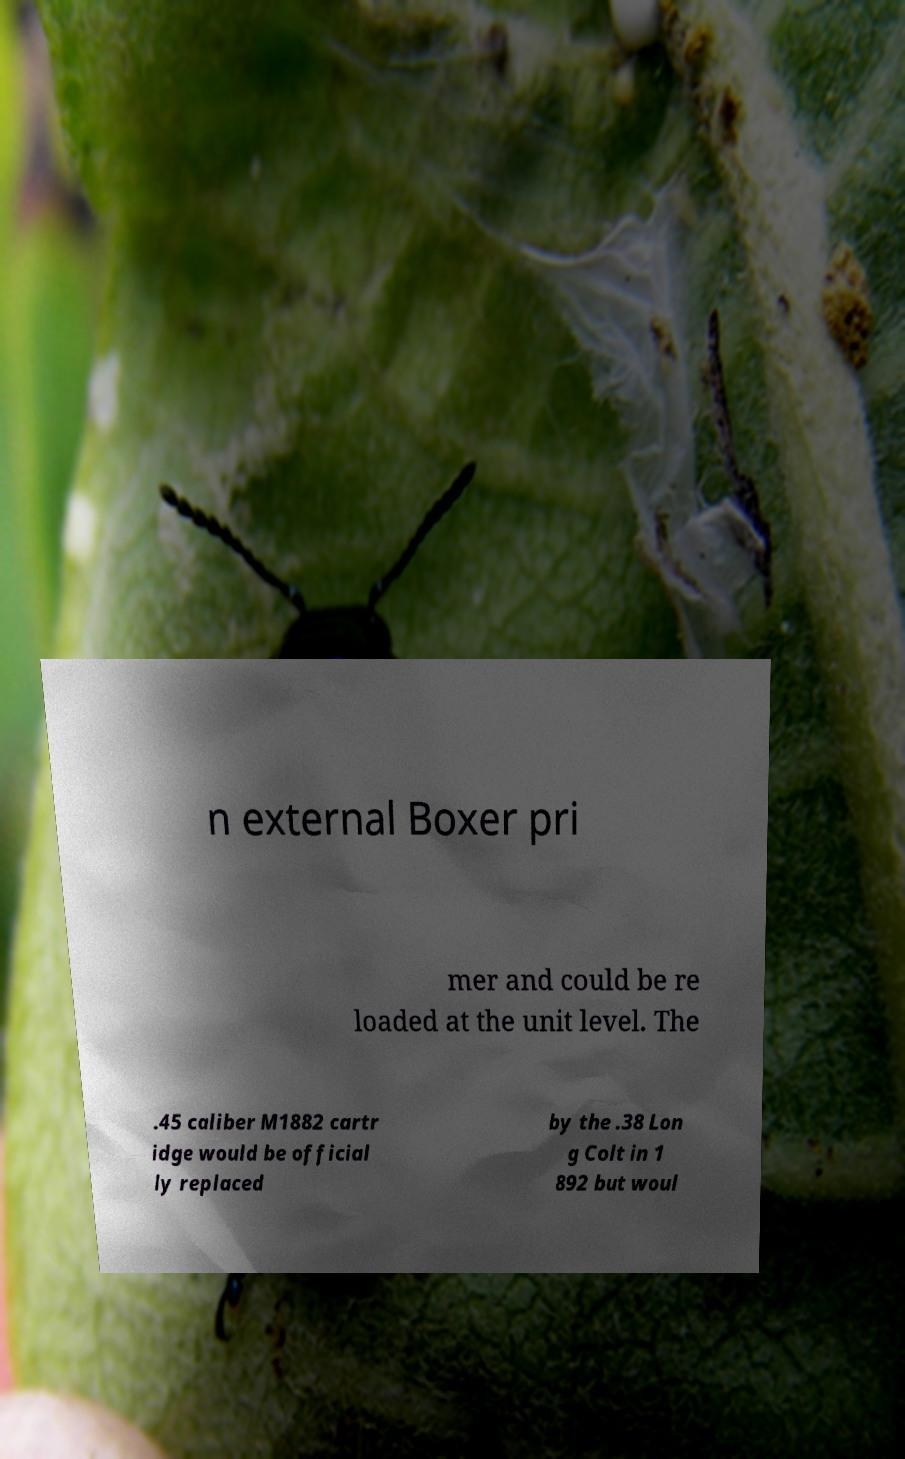I need the written content from this picture converted into text. Can you do that? n external Boxer pri mer and could be re loaded at the unit level. The .45 caliber M1882 cartr idge would be official ly replaced by the .38 Lon g Colt in 1 892 but woul 